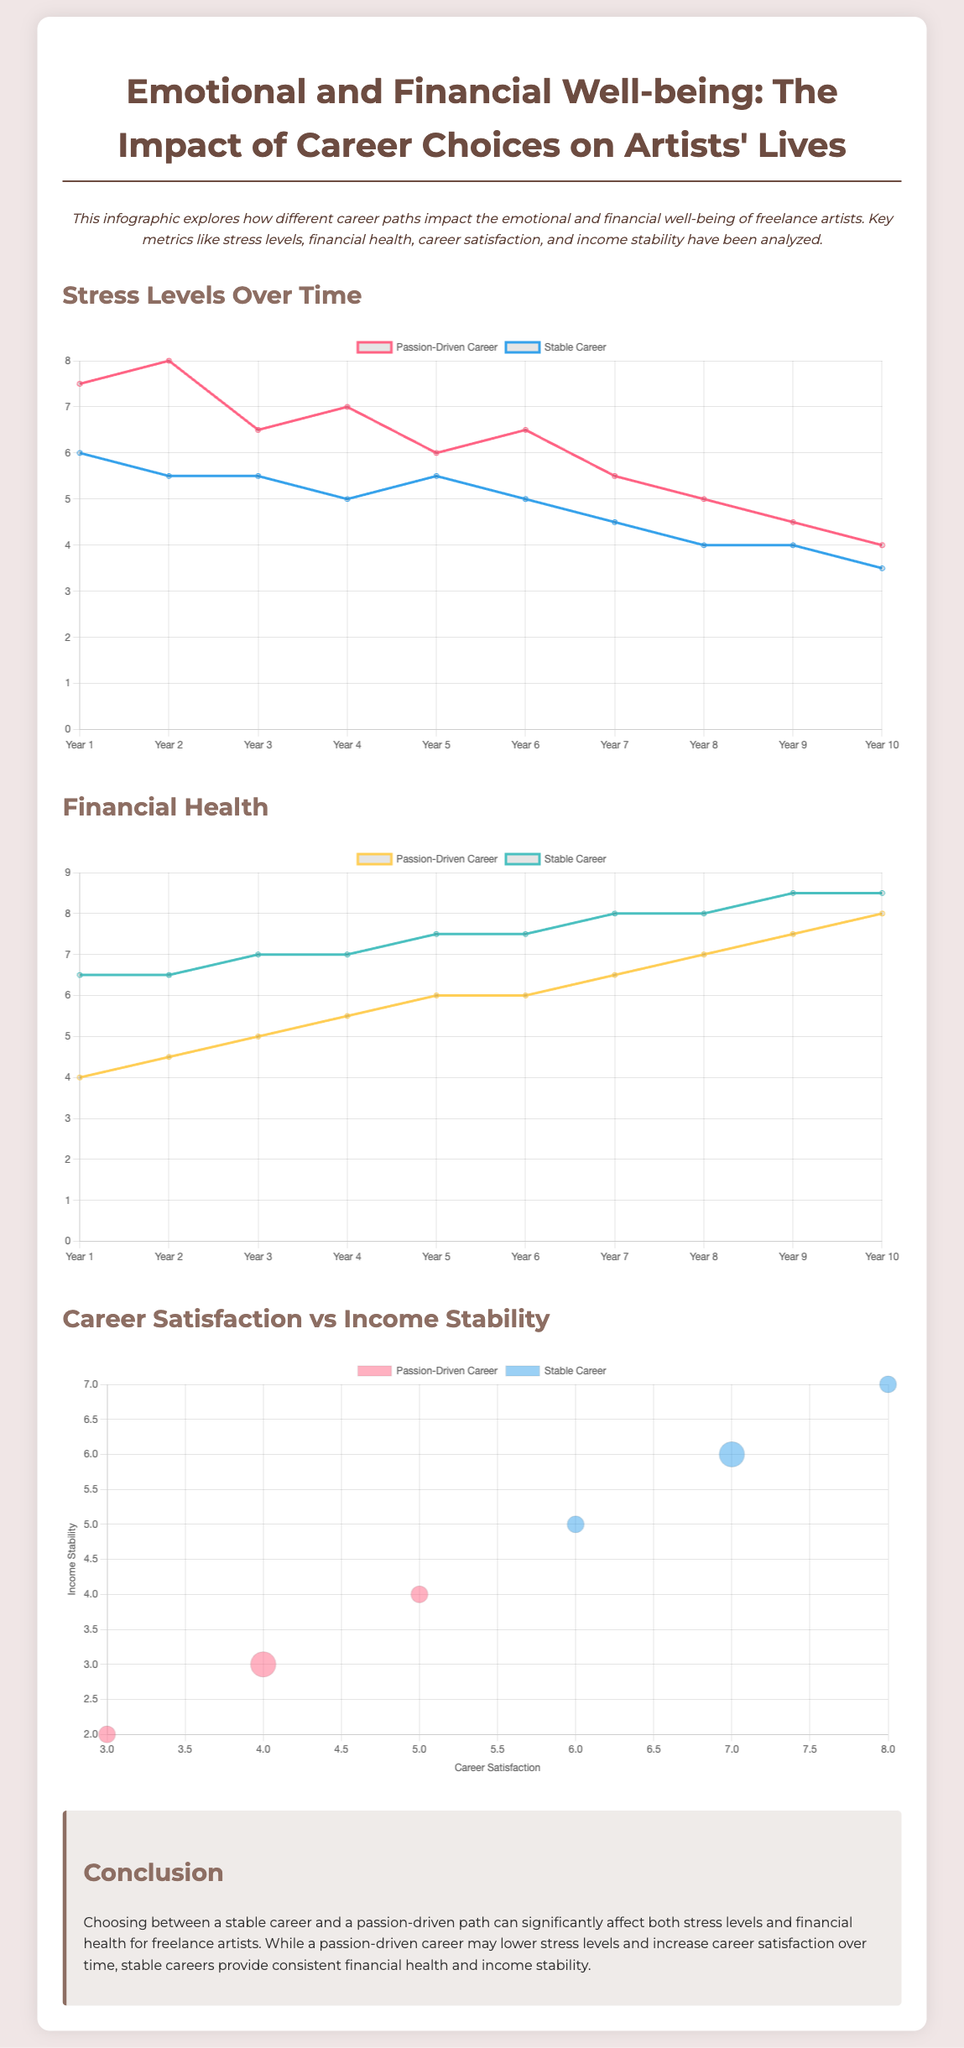What is the main title of the infographic? The title is presented prominently at the top of the document and is "Emotional and Financial Well-being: The Impact of Career Choices on Artists' Lives."
Answer: Emotional and Financial Well-being: The Impact of Career Choices on Artists' Lives In which year does the passion-driven career’s stress level reach its lowest point? The line graph shows that the stress level for a passion-driven career reaches its lowest point at Year 10.
Answer: Year 10 What is the financial health score of stable careers in Year 5? The data for stable careers in Year 5 indicates that the financial health score is 7.5.
Answer: 7.5 How does stress level change for stable careers from Year 1 to Year 10? The line chart illustrates a decreasing trend in stress levels for stable careers from Year 1 to Year 10, going from 6 to 3.5.
Answer: Decreases What is the correlation represented in the bubble chart? The bubble chart represents the correlation between career satisfaction and income stability for both passion-driven and stable careers.
Answer: Correlation between career satisfaction and income stability What is the maximum financial health score for passion-driven careers? The maximum financial health score for passion-driven careers is found in Year 10, which is 8.
Answer: 8 Which career path shows higher stress levels at Year 7? The line graph indicates that passion-driven careers show higher stress levels at Year 7 compared to stable careers.
Answer: Passion-driven careers What visual representation is used to display career satisfaction versus income stability? A bubble chart is utilized to visually represent the correlation between career satisfaction and income stability.
Answer: Bubble chart What trend is observed in stress levels for passion-driven careers over time? The line chart depicts a decreasing trend in stress levels for passion-driven careers over the years.
Answer: Decreasing trend 